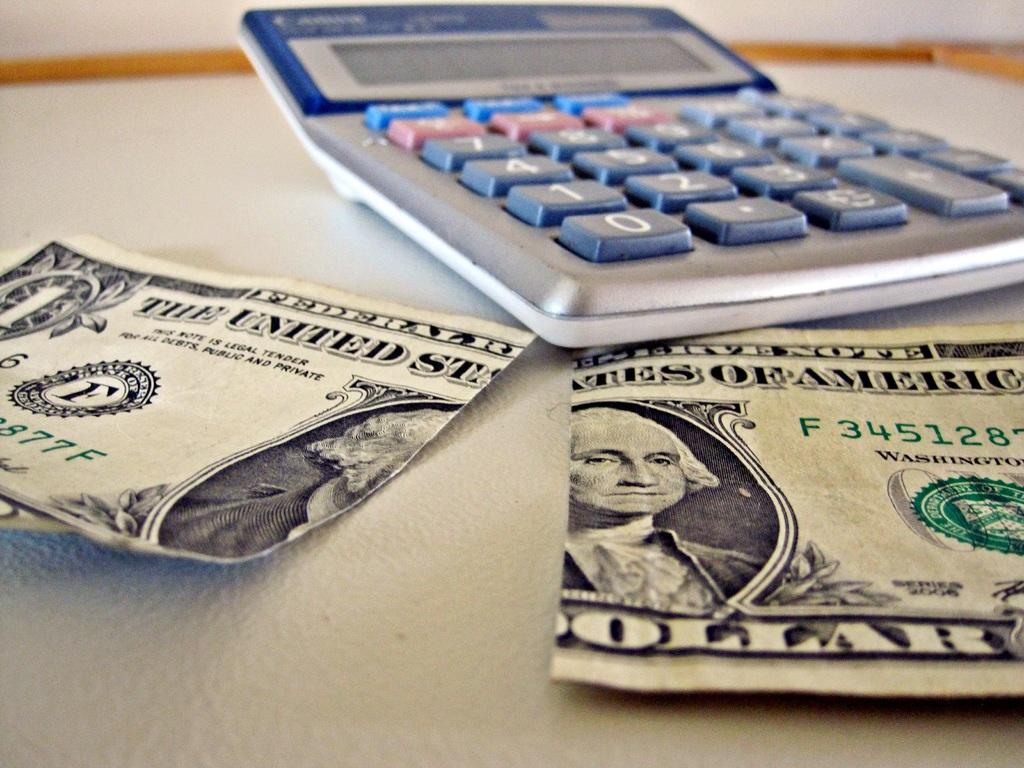<image>
Relay a brief, clear account of the picture shown. A 1 dollar bill split in front of a caluclator 